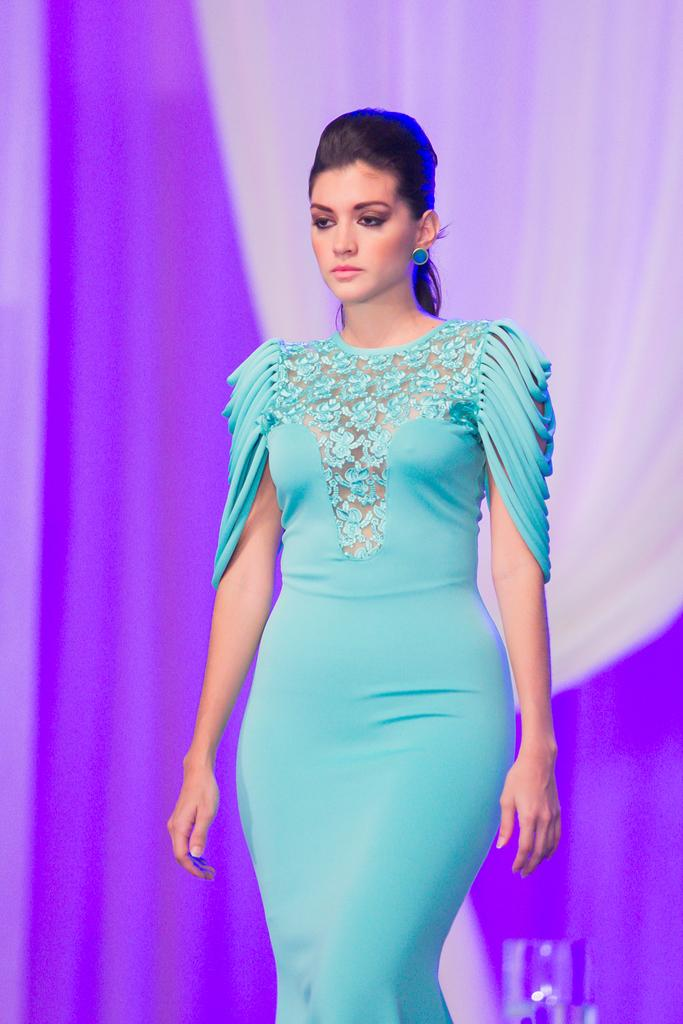What can be inferred about the location of the image? The image was likely taken indoors. Who is present in the image? There is a woman in the image. What is the woman wearing? The woman is wearing a green dress. What is the woman doing in the image? The woman is walking on the ground. What can be seen in the background of the image? There are curtains visible in the background of the image. Can you see the woman's fang in the image? There is no fang present in the image; it is a woman wearing a green dress and walking on the ground. 